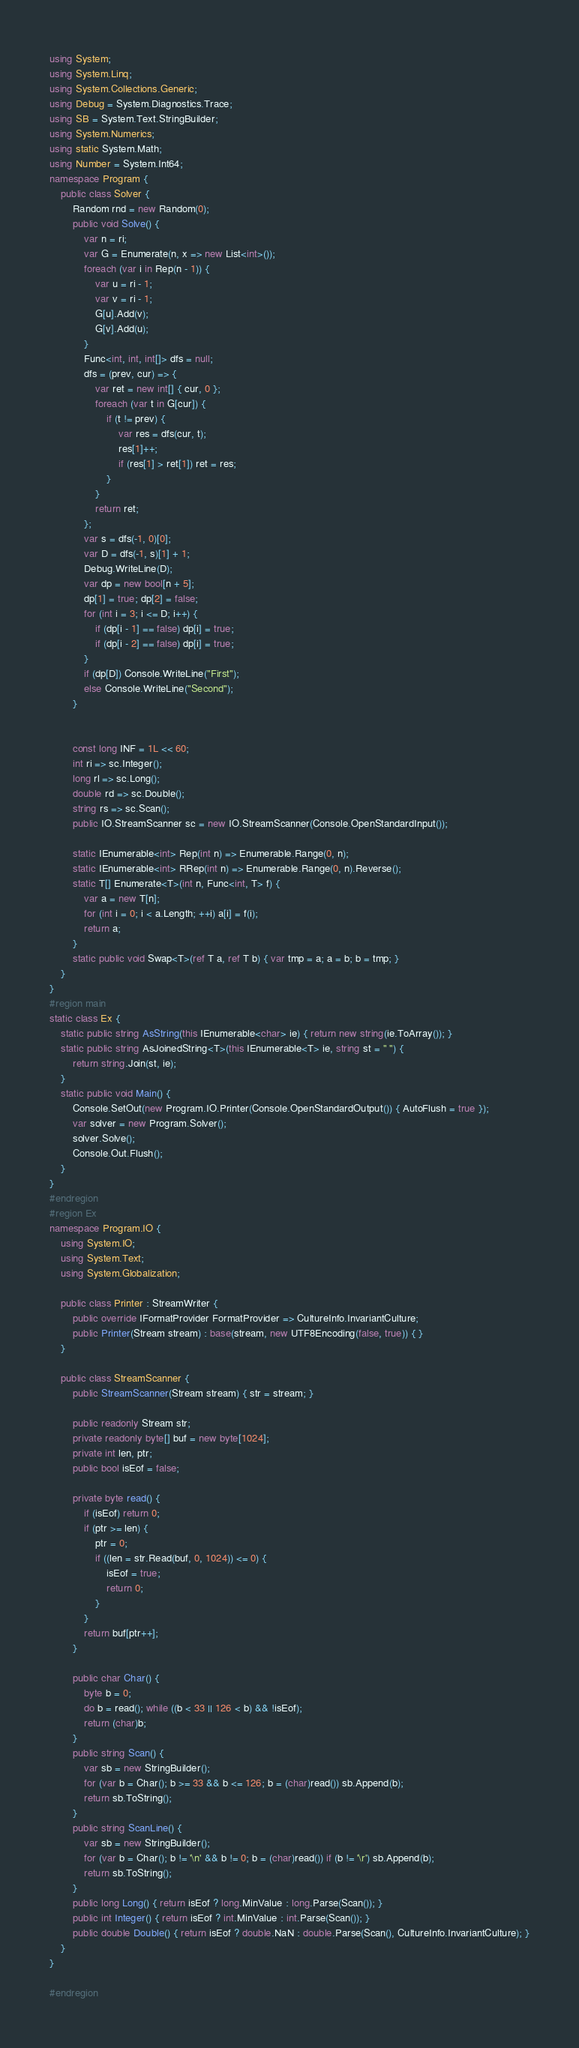Convert code to text. <code><loc_0><loc_0><loc_500><loc_500><_C#_>using System;
using System.Linq;
using System.Collections.Generic;
using Debug = System.Diagnostics.Trace;
using SB = System.Text.StringBuilder;
using System.Numerics;
using static System.Math;
using Number = System.Int64;
namespace Program {
    public class Solver {
        Random rnd = new Random(0);
        public void Solve() {
            var n = ri;
            var G = Enumerate(n, x => new List<int>());
            foreach (var i in Rep(n - 1)) {
                var u = ri - 1;
                var v = ri - 1;
                G[u].Add(v);
                G[v].Add(u);
            }
            Func<int, int, int[]> dfs = null;
            dfs = (prev, cur) => {
                var ret = new int[] { cur, 0 };
                foreach (var t in G[cur]) {
                    if (t != prev) {
                        var res = dfs(cur, t);
                        res[1]++;
                        if (res[1] > ret[1]) ret = res;
                    }
                }
                return ret;
            };
            var s = dfs(-1, 0)[0];
            var D = dfs(-1, s)[1] + 1;
            Debug.WriteLine(D);
            var dp = new bool[n + 5];
            dp[1] = true; dp[2] = false;
            for (int i = 3; i <= D; i++) {
                if (dp[i - 1] == false) dp[i] = true;
                if (dp[i - 2] == false) dp[i] = true;
            }
            if (dp[D]) Console.WriteLine("First");
            else Console.WriteLine("Second");
        }


        const long INF = 1L << 60;
        int ri => sc.Integer();
        long rl => sc.Long();
        double rd => sc.Double();
        string rs => sc.Scan();
        public IO.StreamScanner sc = new IO.StreamScanner(Console.OpenStandardInput());

        static IEnumerable<int> Rep(int n) => Enumerable.Range(0, n);
        static IEnumerable<int> RRep(int n) => Enumerable.Range(0, n).Reverse();
        static T[] Enumerate<T>(int n, Func<int, T> f) {
            var a = new T[n];
            for (int i = 0; i < a.Length; ++i) a[i] = f(i);
            return a;
        }
        static public void Swap<T>(ref T a, ref T b) { var tmp = a; a = b; b = tmp; }
    }
}
#region main
static class Ex {
    static public string AsString(this IEnumerable<char> ie) { return new string(ie.ToArray()); }
    static public string AsJoinedString<T>(this IEnumerable<T> ie, string st = " ") {
        return string.Join(st, ie);
    }
    static public void Main() {
        Console.SetOut(new Program.IO.Printer(Console.OpenStandardOutput()) { AutoFlush = true });
        var solver = new Program.Solver();
        solver.Solve();
        Console.Out.Flush();
    }
}
#endregion
#region Ex
namespace Program.IO {
    using System.IO;
    using System.Text;
    using System.Globalization;

    public class Printer : StreamWriter {
        public override IFormatProvider FormatProvider => CultureInfo.InvariantCulture;
        public Printer(Stream stream) : base(stream, new UTF8Encoding(false, true)) { }
    }

    public class StreamScanner {
        public StreamScanner(Stream stream) { str = stream; }

        public readonly Stream str;
        private readonly byte[] buf = new byte[1024];
        private int len, ptr;
        public bool isEof = false;

        private byte read() {
            if (isEof) return 0;
            if (ptr >= len) {
                ptr = 0;
                if ((len = str.Read(buf, 0, 1024)) <= 0) {
                    isEof = true;
                    return 0;
                }
            }
            return buf[ptr++];
        }

        public char Char() {
            byte b = 0;
            do b = read(); while ((b < 33 || 126 < b) && !isEof);
            return (char)b;
        }
        public string Scan() {
            var sb = new StringBuilder();
            for (var b = Char(); b >= 33 && b <= 126; b = (char)read()) sb.Append(b);
            return sb.ToString();
        }
        public string ScanLine() {
            var sb = new StringBuilder();
            for (var b = Char(); b != '\n' && b != 0; b = (char)read()) if (b != '\r') sb.Append(b);
            return sb.ToString();
        }
        public long Long() { return isEof ? long.MinValue : long.Parse(Scan()); }
        public int Integer() { return isEof ? int.MinValue : int.Parse(Scan()); }
        public double Double() { return isEof ? double.NaN : double.Parse(Scan(), CultureInfo.InvariantCulture); }
    }
}

#endregion
</code> 